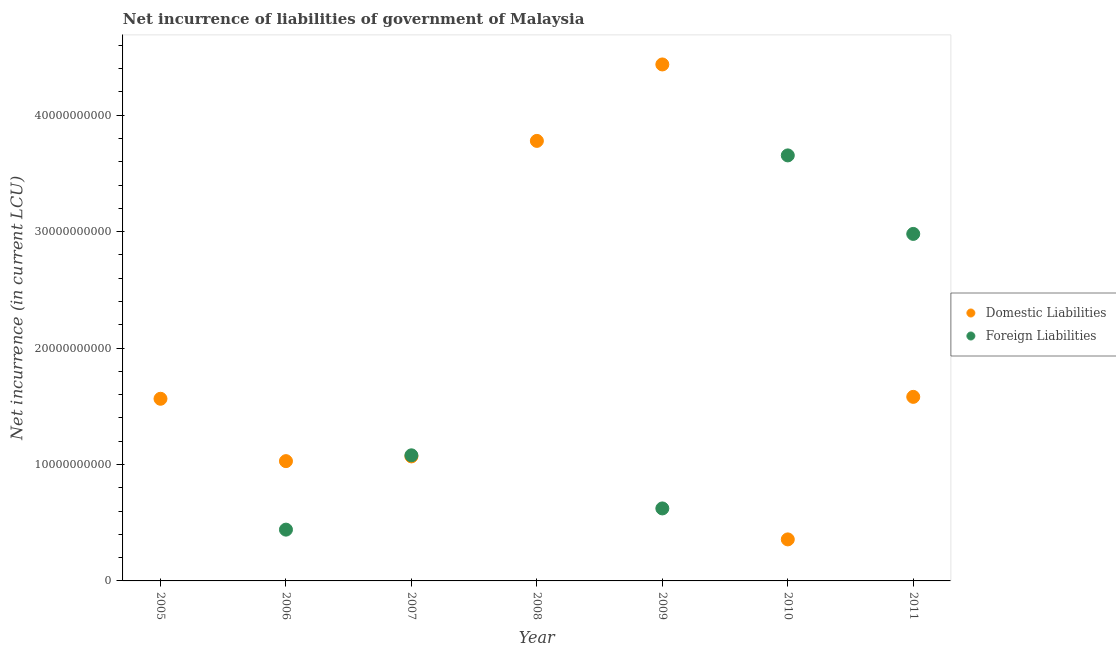How many different coloured dotlines are there?
Give a very brief answer. 2. Across all years, what is the maximum net incurrence of foreign liabilities?
Provide a succinct answer. 3.66e+1. Across all years, what is the minimum net incurrence of domestic liabilities?
Offer a very short reply. 3.57e+09. In which year was the net incurrence of foreign liabilities maximum?
Give a very brief answer. 2010. What is the total net incurrence of domestic liabilities in the graph?
Offer a terse response. 1.38e+11. What is the difference between the net incurrence of foreign liabilities in 2010 and that in 2011?
Provide a short and direct response. 6.74e+09. What is the difference between the net incurrence of domestic liabilities in 2007 and the net incurrence of foreign liabilities in 2006?
Make the answer very short. 6.29e+09. What is the average net incurrence of domestic liabilities per year?
Keep it short and to the point. 1.97e+1. In the year 2006, what is the difference between the net incurrence of foreign liabilities and net incurrence of domestic liabilities?
Your response must be concise. -5.88e+09. In how many years, is the net incurrence of foreign liabilities greater than 34000000000 LCU?
Offer a very short reply. 1. What is the ratio of the net incurrence of foreign liabilities in 2006 to that in 2009?
Keep it short and to the point. 0.71. Is the net incurrence of domestic liabilities in 2006 less than that in 2008?
Make the answer very short. Yes. What is the difference between the highest and the second highest net incurrence of domestic liabilities?
Offer a terse response. 6.57e+09. What is the difference between the highest and the lowest net incurrence of foreign liabilities?
Offer a very short reply. 3.66e+1. Is the sum of the net incurrence of domestic liabilities in 2009 and 2010 greater than the maximum net incurrence of foreign liabilities across all years?
Provide a short and direct response. Yes. Does the net incurrence of domestic liabilities monotonically increase over the years?
Ensure brevity in your answer.  No. Is the net incurrence of foreign liabilities strictly greater than the net incurrence of domestic liabilities over the years?
Your answer should be compact. No. Is the net incurrence of domestic liabilities strictly less than the net incurrence of foreign liabilities over the years?
Ensure brevity in your answer.  No. How many dotlines are there?
Keep it short and to the point. 2. What is the difference between two consecutive major ticks on the Y-axis?
Your response must be concise. 1.00e+1. Does the graph contain any zero values?
Your answer should be very brief. Yes. Where does the legend appear in the graph?
Your answer should be very brief. Center right. How are the legend labels stacked?
Offer a very short reply. Vertical. What is the title of the graph?
Your response must be concise. Net incurrence of liabilities of government of Malaysia. Does "Merchandise exports" appear as one of the legend labels in the graph?
Make the answer very short. No. What is the label or title of the X-axis?
Provide a succinct answer. Year. What is the label or title of the Y-axis?
Offer a very short reply. Net incurrence (in current LCU). What is the Net incurrence (in current LCU) in Domestic Liabilities in 2005?
Make the answer very short. 1.56e+1. What is the Net incurrence (in current LCU) in Domestic Liabilities in 2006?
Offer a very short reply. 1.03e+1. What is the Net incurrence (in current LCU) of Foreign Liabilities in 2006?
Your answer should be very brief. 4.41e+09. What is the Net incurrence (in current LCU) in Domestic Liabilities in 2007?
Your answer should be very brief. 1.07e+1. What is the Net incurrence (in current LCU) of Foreign Liabilities in 2007?
Offer a terse response. 1.08e+1. What is the Net incurrence (in current LCU) in Domestic Liabilities in 2008?
Make the answer very short. 3.78e+1. What is the Net incurrence (in current LCU) of Domestic Liabilities in 2009?
Your answer should be very brief. 4.44e+1. What is the Net incurrence (in current LCU) of Foreign Liabilities in 2009?
Provide a succinct answer. 6.23e+09. What is the Net incurrence (in current LCU) in Domestic Liabilities in 2010?
Provide a short and direct response. 3.57e+09. What is the Net incurrence (in current LCU) in Foreign Liabilities in 2010?
Ensure brevity in your answer.  3.66e+1. What is the Net incurrence (in current LCU) of Domestic Liabilities in 2011?
Your answer should be very brief. 1.58e+1. What is the Net incurrence (in current LCU) in Foreign Liabilities in 2011?
Keep it short and to the point. 2.98e+1. Across all years, what is the maximum Net incurrence (in current LCU) of Domestic Liabilities?
Keep it short and to the point. 4.44e+1. Across all years, what is the maximum Net incurrence (in current LCU) in Foreign Liabilities?
Offer a terse response. 3.66e+1. Across all years, what is the minimum Net incurrence (in current LCU) in Domestic Liabilities?
Your answer should be very brief. 3.57e+09. What is the total Net incurrence (in current LCU) in Domestic Liabilities in the graph?
Give a very brief answer. 1.38e+11. What is the total Net incurrence (in current LCU) in Foreign Liabilities in the graph?
Make the answer very short. 8.78e+1. What is the difference between the Net incurrence (in current LCU) of Domestic Liabilities in 2005 and that in 2006?
Provide a short and direct response. 5.36e+09. What is the difference between the Net incurrence (in current LCU) of Domestic Liabilities in 2005 and that in 2007?
Offer a terse response. 4.95e+09. What is the difference between the Net incurrence (in current LCU) in Domestic Liabilities in 2005 and that in 2008?
Provide a short and direct response. -2.22e+1. What is the difference between the Net incurrence (in current LCU) of Domestic Liabilities in 2005 and that in 2009?
Provide a short and direct response. -2.87e+1. What is the difference between the Net incurrence (in current LCU) in Domestic Liabilities in 2005 and that in 2010?
Offer a terse response. 1.21e+1. What is the difference between the Net incurrence (in current LCU) of Domestic Liabilities in 2005 and that in 2011?
Offer a terse response. -1.64e+08. What is the difference between the Net incurrence (in current LCU) of Domestic Liabilities in 2006 and that in 2007?
Offer a terse response. -4.07e+08. What is the difference between the Net incurrence (in current LCU) in Foreign Liabilities in 2006 and that in 2007?
Make the answer very short. -6.38e+09. What is the difference between the Net incurrence (in current LCU) of Domestic Liabilities in 2006 and that in 2008?
Give a very brief answer. -2.75e+1. What is the difference between the Net incurrence (in current LCU) in Domestic Liabilities in 2006 and that in 2009?
Offer a very short reply. -3.41e+1. What is the difference between the Net incurrence (in current LCU) of Foreign Liabilities in 2006 and that in 2009?
Offer a very short reply. -1.82e+09. What is the difference between the Net incurrence (in current LCU) in Domestic Liabilities in 2006 and that in 2010?
Provide a short and direct response. 6.72e+09. What is the difference between the Net incurrence (in current LCU) in Foreign Liabilities in 2006 and that in 2010?
Your answer should be compact. -3.21e+1. What is the difference between the Net incurrence (in current LCU) of Domestic Liabilities in 2006 and that in 2011?
Give a very brief answer. -5.52e+09. What is the difference between the Net incurrence (in current LCU) in Foreign Liabilities in 2006 and that in 2011?
Offer a very short reply. -2.54e+1. What is the difference between the Net incurrence (in current LCU) in Domestic Liabilities in 2007 and that in 2008?
Provide a succinct answer. -2.71e+1. What is the difference between the Net incurrence (in current LCU) in Domestic Liabilities in 2007 and that in 2009?
Your response must be concise. -3.37e+1. What is the difference between the Net incurrence (in current LCU) in Foreign Liabilities in 2007 and that in 2009?
Give a very brief answer. 4.56e+09. What is the difference between the Net incurrence (in current LCU) of Domestic Liabilities in 2007 and that in 2010?
Provide a short and direct response. 7.13e+09. What is the difference between the Net incurrence (in current LCU) of Foreign Liabilities in 2007 and that in 2010?
Your response must be concise. -2.58e+1. What is the difference between the Net incurrence (in current LCU) of Domestic Liabilities in 2007 and that in 2011?
Make the answer very short. -5.11e+09. What is the difference between the Net incurrence (in current LCU) of Foreign Liabilities in 2007 and that in 2011?
Offer a terse response. -1.90e+1. What is the difference between the Net incurrence (in current LCU) of Domestic Liabilities in 2008 and that in 2009?
Give a very brief answer. -6.57e+09. What is the difference between the Net incurrence (in current LCU) in Domestic Liabilities in 2008 and that in 2010?
Offer a very short reply. 3.42e+1. What is the difference between the Net incurrence (in current LCU) of Domestic Liabilities in 2008 and that in 2011?
Your answer should be very brief. 2.20e+1. What is the difference between the Net incurrence (in current LCU) of Domestic Liabilities in 2009 and that in 2010?
Keep it short and to the point. 4.08e+1. What is the difference between the Net incurrence (in current LCU) of Foreign Liabilities in 2009 and that in 2010?
Your response must be concise. -3.03e+1. What is the difference between the Net incurrence (in current LCU) of Domestic Liabilities in 2009 and that in 2011?
Your answer should be compact. 2.86e+1. What is the difference between the Net incurrence (in current LCU) in Foreign Liabilities in 2009 and that in 2011?
Ensure brevity in your answer.  -2.36e+1. What is the difference between the Net incurrence (in current LCU) of Domestic Liabilities in 2010 and that in 2011?
Make the answer very short. -1.22e+1. What is the difference between the Net incurrence (in current LCU) in Foreign Liabilities in 2010 and that in 2011?
Offer a very short reply. 6.74e+09. What is the difference between the Net incurrence (in current LCU) in Domestic Liabilities in 2005 and the Net incurrence (in current LCU) in Foreign Liabilities in 2006?
Provide a short and direct response. 1.12e+1. What is the difference between the Net incurrence (in current LCU) of Domestic Liabilities in 2005 and the Net incurrence (in current LCU) of Foreign Liabilities in 2007?
Your answer should be very brief. 4.86e+09. What is the difference between the Net incurrence (in current LCU) of Domestic Liabilities in 2005 and the Net incurrence (in current LCU) of Foreign Liabilities in 2009?
Your response must be concise. 9.42e+09. What is the difference between the Net incurrence (in current LCU) of Domestic Liabilities in 2005 and the Net incurrence (in current LCU) of Foreign Liabilities in 2010?
Your answer should be very brief. -2.09e+1. What is the difference between the Net incurrence (in current LCU) in Domestic Liabilities in 2005 and the Net incurrence (in current LCU) in Foreign Liabilities in 2011?
Keep it short and to the point. -1.42e+1. What is the difference between the Net incurrence (in current LCU) of Domestic Liabilities in 2006 and the Net incurrence (in current LCU) of Foreign Liabilities in 2007?
Give a very brief answer. -4.99e+08. What is the difference between the Net incurrence (in current LCU) in Domestic Liabilities in 2006 and the Net incurrence (in current LCU) in Foreign Liabilities in 2009?
Give a very brief answer. 4.06e+09. What is the difference between the Net incurrence (in current LCU) of Domestic Liabilities in 2006 and the Net incurrence (in current LCU) of Foreign Liabilities in 2010?
Provide a short and direct response. -2.63e+1. What is the difference between the Net incurrence (in current LCU) of Domestic Liabilities in 2006 and the Net incurrence (in current LCU) of Foreign Liabilities in 2011?
Your answer should be very brief. -1.95e+1. What is the difference between the Net incurrence (in current LCU) in Domestic Liabilities in 2007 and the Net incurrence (in current LCU) in Foreign Liabilities in 2009?
Ensure brevity in your answer.  4.47e+09. What is the difference between the Net incurrence (in current LCU) in Domestic Liabilities in 2007 and the Net incurrence (in current LCU) in Foreign Liabilities in 2010?
Make the answer very short. -2.59e+1. What is the difference between the Net incurrence (in current LCU) in Domestic Liabilities in 2007 and the Net incurrence (in current LCU) in Foreign Liabilities in 2011?
Give a very brief answer. -1.91e+1. What is the difference between the Net incurrence (in current LCU) of Domestic Liabilities in 2008 and the Net incurrence (in current LCU) of Foreign Liabilities in 2009?
Ensure brevity in your answer.  3.16e+1. What is the difference between the Net incurrence (in current LCU) in Domestic Liabilities in 2008 and the Net incurrence (in current LCU) in Foreign Liabilities in 2010?
Provide a succinct answer. 1.25e+09. What is the difference between the Net incurrence (in current LCU) of Domestic Liabilities in 2008 and the Net incurrence (in current LCU) of Foreign Liabilities in 2011?
Your response must be concise. 7.99e+09. What is the difference between the Net incurrence (in current LCU) of Domestic Liabilities in 2009 and the Net incurrence (in current LCU) of Foreign Liabilities in 2010?
Give a very brief answer. 7.81e+09. What is the difference between the Net incurrence (in current LCU) in Domestic Liabilities in 2009 and the Net incurrence (in current LCU) in Foreign Liabilities in 2011?
Your answer should be compact. 1.46e+1. What is the difference between the Net incurrence (in current LCU) in Domestic Liabilities in 2010 and the Net incurrence (in current LCU) in Foreign Liabilities in 2011?
Your answer should be very brief. -2.62e+1. What is the average Net incurrence (in current LCU) in Domestic Liabilities per year?
Your response must be concise. 1.97e+1. What is the average Net incurrence (in current LCU) of Foreign Liabilities per year?
Provide a succinct answer. 1.25e+1. In the year 2006, what is the difference between the Net incurrence (in current LCU) in Domestic Liabilities and Net incurrence (in current LCU) in Foreign Liabilities?
Offer a terse response. 5.88e+09. In the year 2007, what is the difference between the Net incurrence (in current LCU) of Domestic Liabilities and Net incurrence (in current LCU) of Foreign Liabilities?
Provide a short and direct response. -9.14e+07. In the year 2009, what is the difference between the Net incurrence (in current LCU) in Domestic Liabilities and Net incurrence (in current LCU) in Foreign Liabilities?
Provide a succinct answer. 3.81e+1. In the year 2010, what is the difference between the Net incurrence (in current LCU) of Domestic Liabilities and Net incurrence (in current LCU) of Foreign Liabilities?
Make the answer very short. -3.30e+1. In the year 2011, what is the difference between the Net incurrence (in current LCU) of Domestic Liabilities and Net incurrence (in current LCU) of Foreign Liabilities?
Provide a succinct answer. -1.40e+1. What is the ratio of the Net incurrence (in current LCU) in Domestic Liabilities in 2005 to that in 2006?
Give a very brief answer. 1.52. What is the ratio of the Net incurrence (in current LCU) of Domestic Liabilities in 2005 to that in 2007?
Offer a very short reply. 1.46. What is the ratio of the Net incurrence (in current LCU) of Domestic Liabilities in 2005 to that in 2008?
Offer a terse response. 0.41. What is the ratio of the Net incurrence (in current LCU) in Domestic Liabilities in 2005 to that in 2009?
Your response must be concise. 0.35. What is the ratio of the Net incurrence (in current LCU) of Domestic Liabilities in 2005 to that in 2010?
Ensure brevity in your answer.  4.39. What is the ratio of the Net incurrence (in current LCU) of Domestic Liabilities in 2006 to that in 2007?
Your response must be concise. 0.96. What is the ratio of the Net incurrence (in current LCU) of Foreign Liabilities in 2006 to that in 2007?
Offer a terse response. 0.41. What is the ratio of the Net incurrence (in current LCU) of Domestic Liabilities in 2006 to that in 2008?
Offer a very short reply. 0.27. What is the ratio of the Net incurrence (in current LCU) of Domestic Liabilities in 2006 to that in 2009?
Offer a terse response. 0.23. What is the ratio of the Net incurrence (in current LCU) of Foreign Liabilities in 2006 to that in 2009?
Give a very brief answer. 0.71. What is the ratio of the Net incurrence (in current LCU) in Domestic Liabilities in 2006 to that in 2010?
Ensure brevity in your answer.  2.88. What is the ratio of the Net incurrence (in current LCU) in Foreign Liabilities in 2006 to that in 2010?
Give a very brief answer. 0.12. What is the ratio of the Net incurrence (in current LCU) in Domestic Liabilities in 2006 to that in 2011?
Your response must be concise. 0.65. What is the ratio of the Net incurrence (in current LCU) in Foreign Liabilities in 2006 to that in 2011?
Ensure brevity in your answer.  0.15. What is the ratio of the Net incurrence (in current LCU) in Domestic Liabilities in 2007 to that in 2008?
Offer a very short reply. 0.28. What is the ratio of the Net incurrence (in current LCU) of Domestic Liabilities in 2007 to that in 2009?
Provide a succinct answer. 0.24. What is the ratio of the Net incurrence (in current LCU) in Foreign Liabilities in 2007 to that in 2009?
Your response must be concise. 1.73. What is the ratio of the Net incurrence (in current LCU) of Domestic Liabilities in 2007 to that in 2010?
Your answer should be compact. 3. What is the ratio of the Net incurrence (in current LCU) of Foreign Liabilities in 2007 to that in 2010?
Offer a very short reply. 0.3. What is the ratio of the Net incurrence (in current LCU) in Domestic Liabilities in 2007 to that in 2011?
Ensure brevity in your answer.  0.68. What is the ratio of the Net incurrence (in current LCU) in Foreign Liabilities in 2007 to that in 2011?
Your answer should be compact. 0.36. What is the ratio of the Net incurrence (in current LCU) of Domestic Liabilities in 2008 to that in 2009?
Your answer should be very brief. 0.85. What is the ratio of the Net incurrence (in current LCU) of Domestic Liabilities in 2008 to that in 2010?
Give a very brief answer. 10.6. What is the ratio of the Net incurrence (in current LCU) in Domestic Liabilities in 2008 to that in 2011?
Make the answer very short. 2.39. What is the ratio of the Net incurrence (in current LCU) of Domestic Liabilities in 2009 to that in 2010?
Offer a terse response. 12.44. What is the ratio of the Net incurrence (in current LCU) of Foreign Liabilities in 2009 to that in 2010?
Your answer should be compact. 0.17. What is the ratio of the Net incurrence (in current LCU) of Domestic Liabilities in 2009 to that in 2011?
Offer a very short reply. 2.81. What is the ratio of the Net incurrence (in current LCU) of Foreign Liabilities in 2009 to that in 2011?
Your answer should be very brief. 0.21. What is the ratio of the Net incurrence (in current LCU) of Domestic Liabilities in 2010 to that in 2011?
Give a very brief answer. 0.23. What is the ratio of the Net incurrence (in current LCU) of Foreign Liabilities in 2010 to that in 2011?
Provide a succinct answer. 1.23. What is the difference between the highest and the second highest Net incurrence (in current LCU) in Domestic Liabilities?
Offer a very short reply. 6.57e+09. What is the difference between the highest and the second highest Net incurrence (in current LCU) in Foreign Liabilities?
Keep it short and to the point. 6.74e+09. What is the difference between the highest and the lowest Net incurrence (in current LCU) in Domestic Liabilities?
Provide a short and direct response. 4.08e+1. What is the difference between the highest and the lowest Net incurrence (in current LCU) of Foreign Liabilities?
Keep it short and to the point. 3.66e+1. 